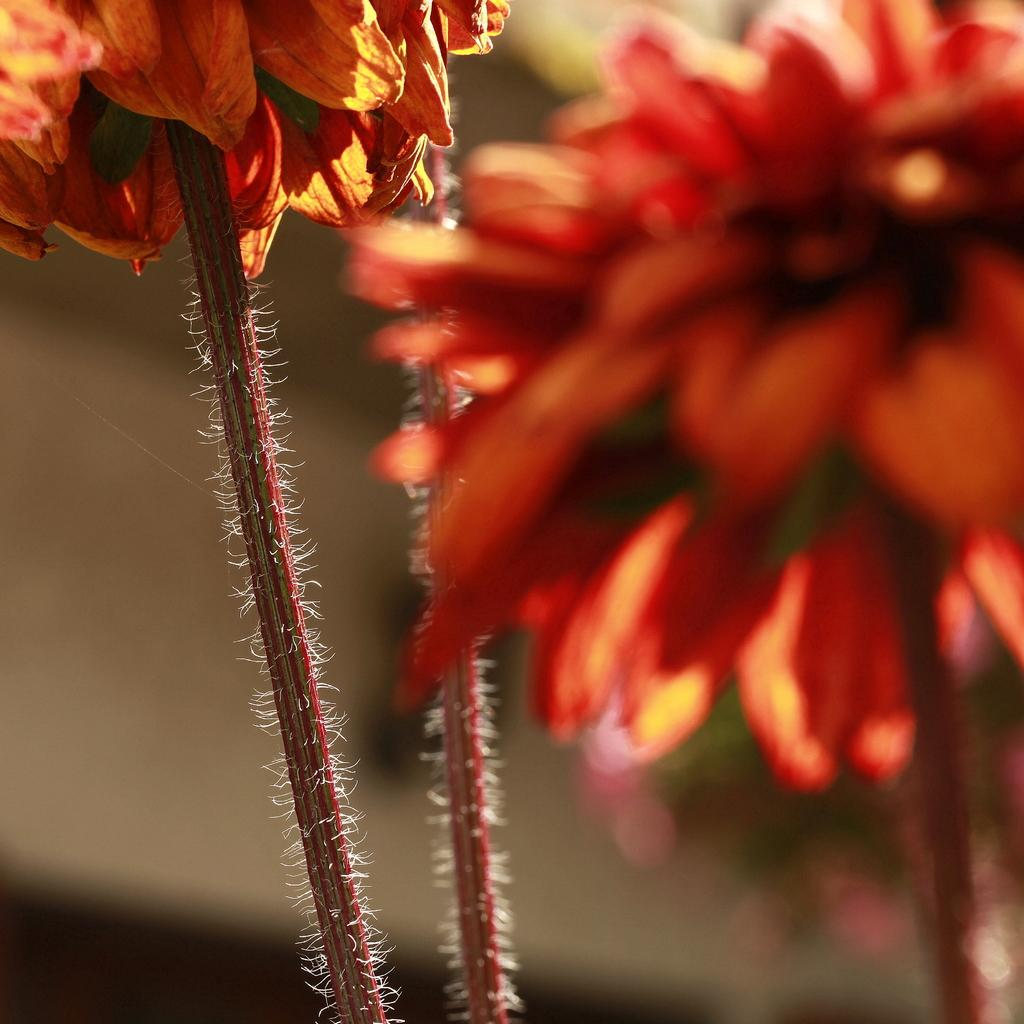What is the main subject of the image? The main subject of the image is stems with flowers. Can you describe the flowers in the image? Unfortunately, the facts provided do not give any details about the flowers themselves. What can be seen in the background of the image? The background of the image is blurry. How many eggs are visible in the wilderness in the image? There are no eggs or wilderness present in the image; it features stems with flowers and a blurry background. 